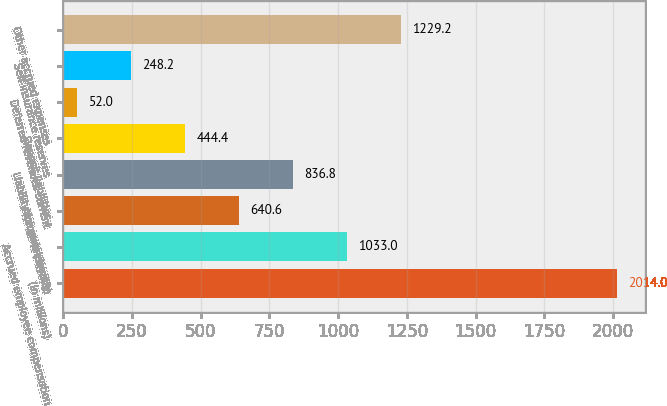<chart> <loc_0><loc_0><loc_500><loc_500><bar_chart><fcel>(in millions)<fcel>Accrued employee compensation<fcel>Accounts payable<fcel>Liability for guest loyalty<fcel>Deposit liabilities<fcel>Deferred revenues current<fcel>Self-insurance reserves<fcel>Other accrued expenses<nl><fcel>2014<fcel>1033<fcel>640.6<fcel>836.8<fcel>444.4<fcel>52<fcel>248.2<fcel>1229.2<nl></chart> 